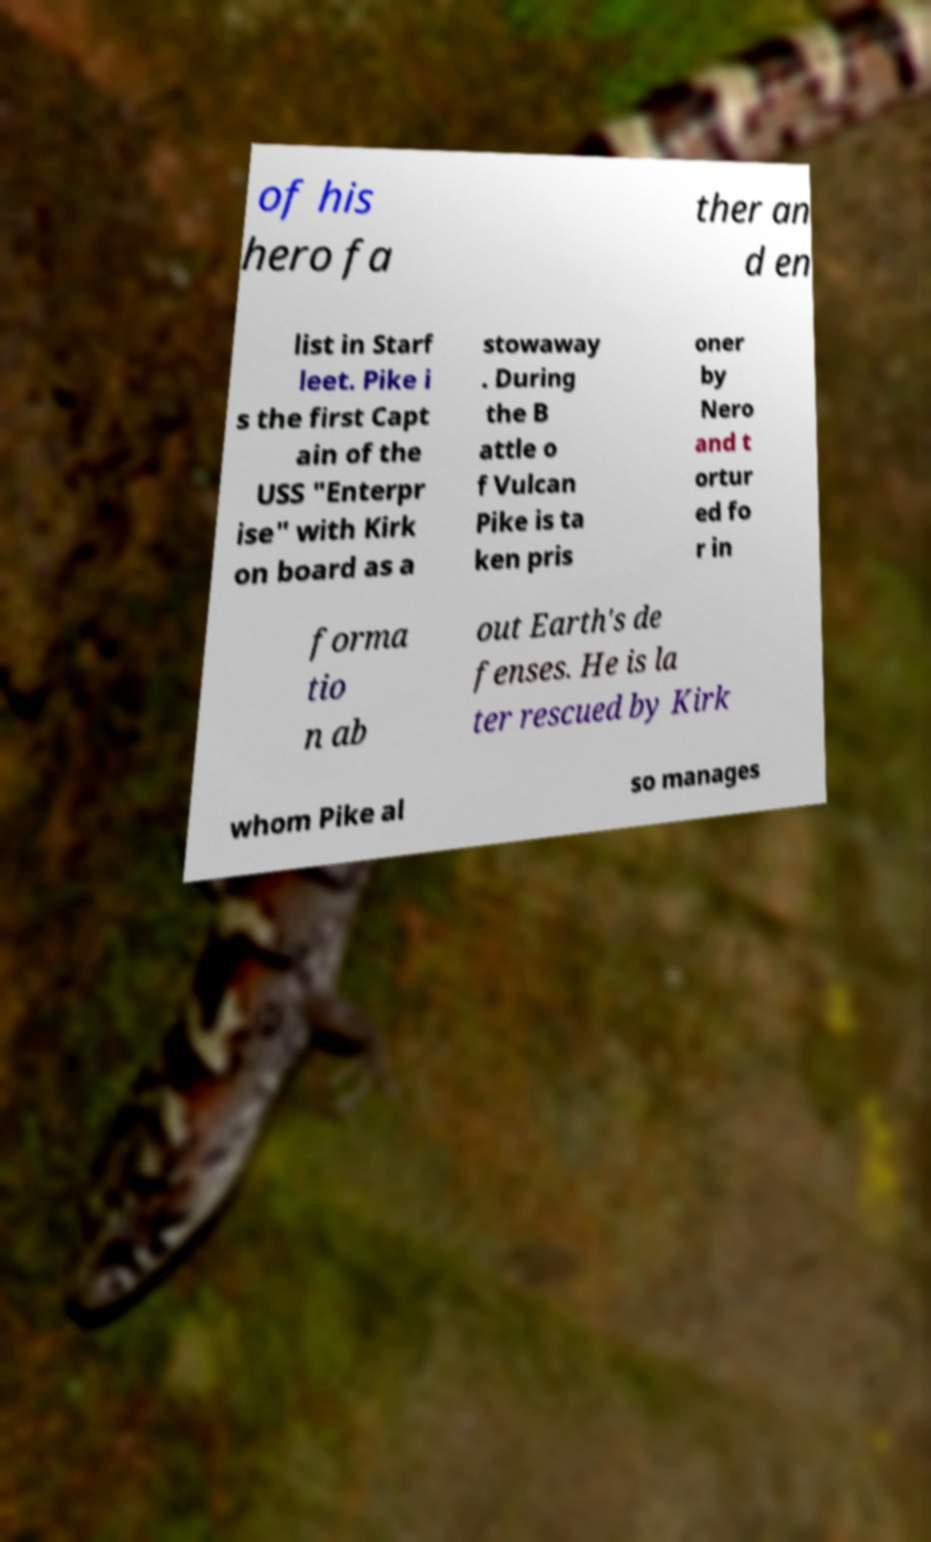For documentation purposes, I need the text within this image transcribed. Could you provide that? of his hero fa ther an d en list in Starf leet. Pike i s the first Capt ain of the USS "Enterpr ise" with Kirk on board as a stowaway . During the B attle o f Vulcan Pike is ta ken pris oner by Nero and t ortur ed fo r in forma tio n ab out Earth's de fenses. He is la ter rescued by Kirk whom Pike al so manages 